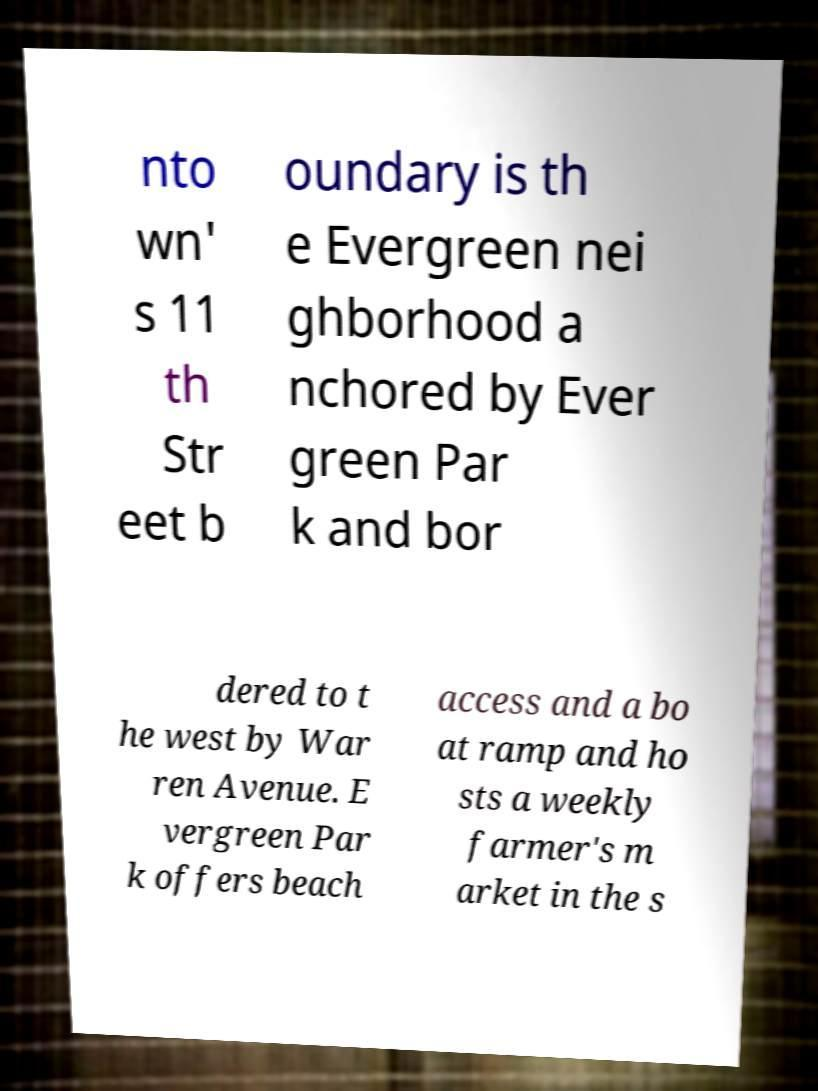I need the written content from this picture converted into text. Can you do that? nto wn' s 11 th Str eet b oundary is th e Evergreen nei ghborhood a nchored by Ever green Par k and bor dered to t he west by War ren Avenue. E vergreen Par k offers beach access and a bo at ramp and ho sts a weekly farmer's m arket in the s 